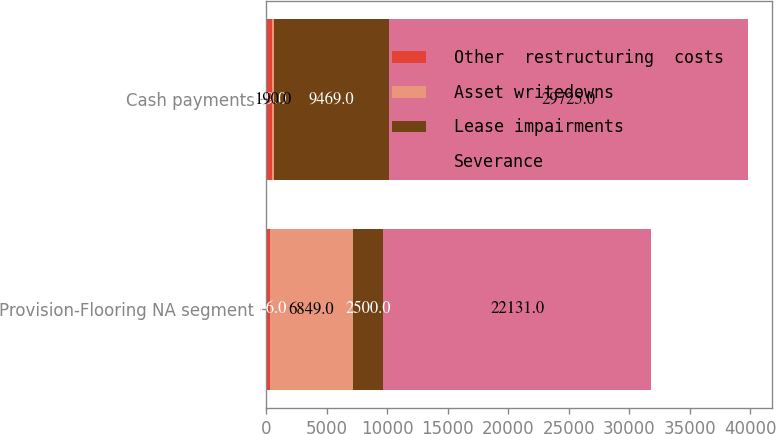<chart> <loc_0><loc_0><loc_500><loc_500><stacked_bar_chart><ecel><fcel>Provision-Flooring NA segment<fcel>Cash payments<nl><fcel>Other  restructuring  costs<fcel>316<fcel>449<nl><fcel>Asset writedowns<fcel>6849<fcel>190<nl><fcel>Lease impairments<fcel>2500<fcel>9469<nl><fcel>Severance<fcel>22131<fcel>29725<nl></chart> 